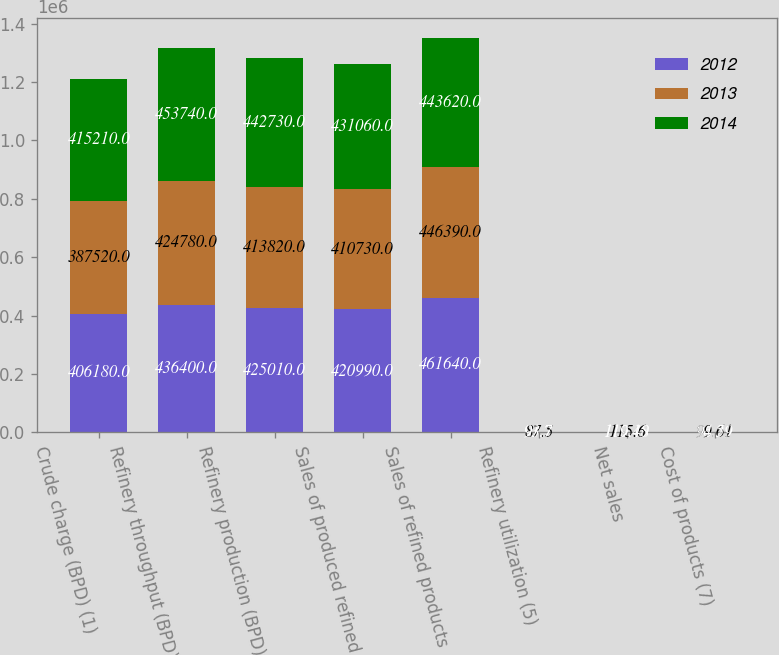Convert chart to OTSL. <chart><loc_0><loc_0><loc_500><loc_500><stacked_bar_chart><ecel><fcel>Crude charge (BPD) (1)<fcel>Refinery throughput (BPD) (2)<fcel>Refinery production (BPD) (3)<fcel>Sales of produced refined<fcel>Sales of refined products<fcel>Refinery utilization (5)<fcel>Net sales<fcel>Cost of products (7)<nl><fcel>2012<fcel>406180<fcel>436400<fcel>425010<fcel>420990<fcel>461640<fcel>91.7<fcel>110.19<fcel>96.21<nl><fcel>2013<fcel>387520<fcel>424780<fcel>413820<fcel>410730<fcel>446390<fcel>87.5<fcel>115.6<fcel>99.61<nl><fcel>2014<fcel>415210<fcel>453740<fcel>442730<fcel>431060<fcel>443620<fcel>93.7<fcel>119.48<fcel>94.59<nl></chart> 